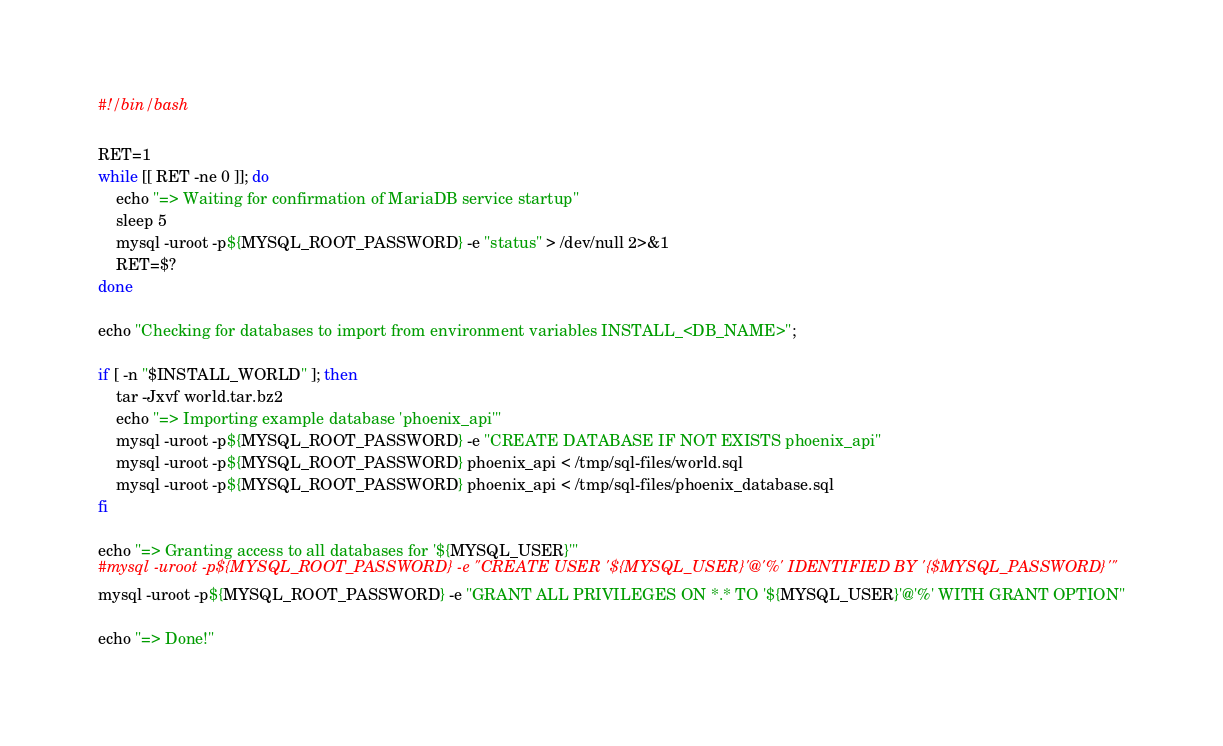Convert code to text. <code><loc_0><loc_0><loc_500><loc_500><_Bash_>#!/bin/bash

RET=1
while [[ RET -ne 0 ]]; do
    echo "=> Waiting for confirmation of MariaDB service startup"
    sleep 5
    mysql -uroot -p${MYSQL_ROOT_PASSWORD} -e "status" > /dev/null 2>&1
    RET=$?
done

echo "Checking for databases to import from environment variables INSTALL_<DB_NAME>";

if [ -n "$INSTALL_WORLD" ]; then
    tar -Jxvf world.tar.bz2
    echo "=> Importing example database 'phoenix_api'"
    mysql -uroot -p${MYSQL_ROOT_PASSWORD} -e "CREATE DATABASE IF NOT EXISTS phoenix_api"
    mysql -uroot -p${MYSQL_ROOT_PASSWORD} phoenix_api < /tmp/sql-files/world.sql
    mysql -uroot -p${MYSQL_ROOT_PASSWORD} phoenix_api < /tmp/sql-files/phoenix_database.sql
fi

echo "=> Granting access to all databases for '${MYSQL_USER}'"
#mysql -uroot -p${MYSQL_ROOT_PASSWORD} -e "CREATE USER '${MYSQL_USER}'@'%' IDENTIFIED BY '{$MYSQL_PASSWORD}'"
mysql -uroot -p${MYSQL_ROOT_PASSWORD} -e "GRANT ALL PRIVILEGES ON *.* TO '${MYSQL_USER}'@'%' WITH GRANT OPTION"

echo "=> Done!"
</code> 